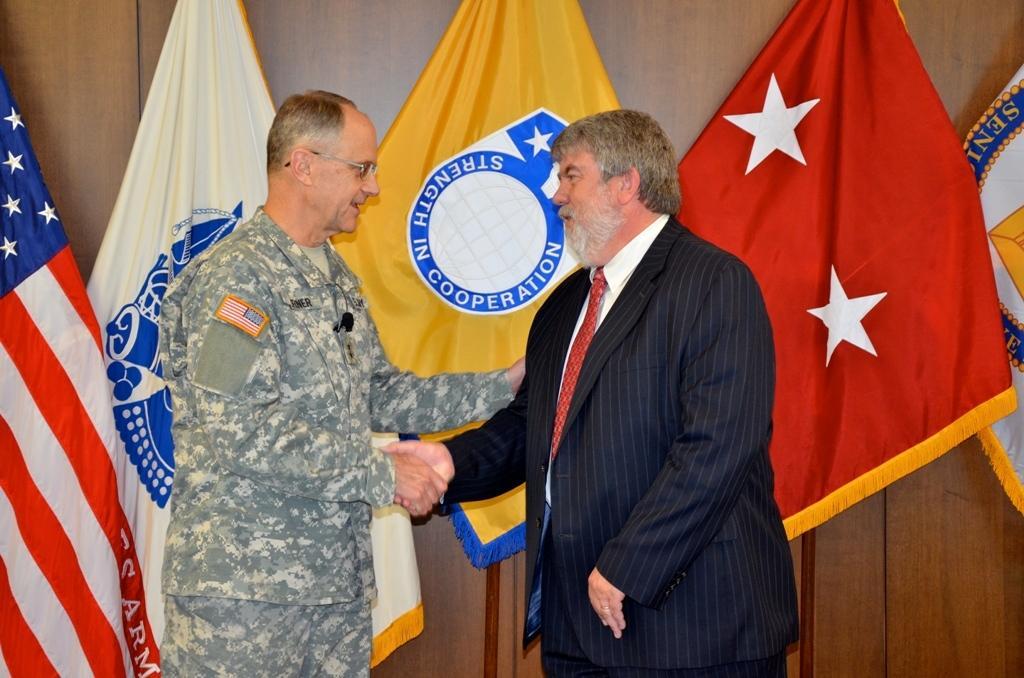In one or two sentences, can you explain what this image depicts? In this image we can see two persons shaking hands. Behind the persons we can see the flags and a wooden wall. 